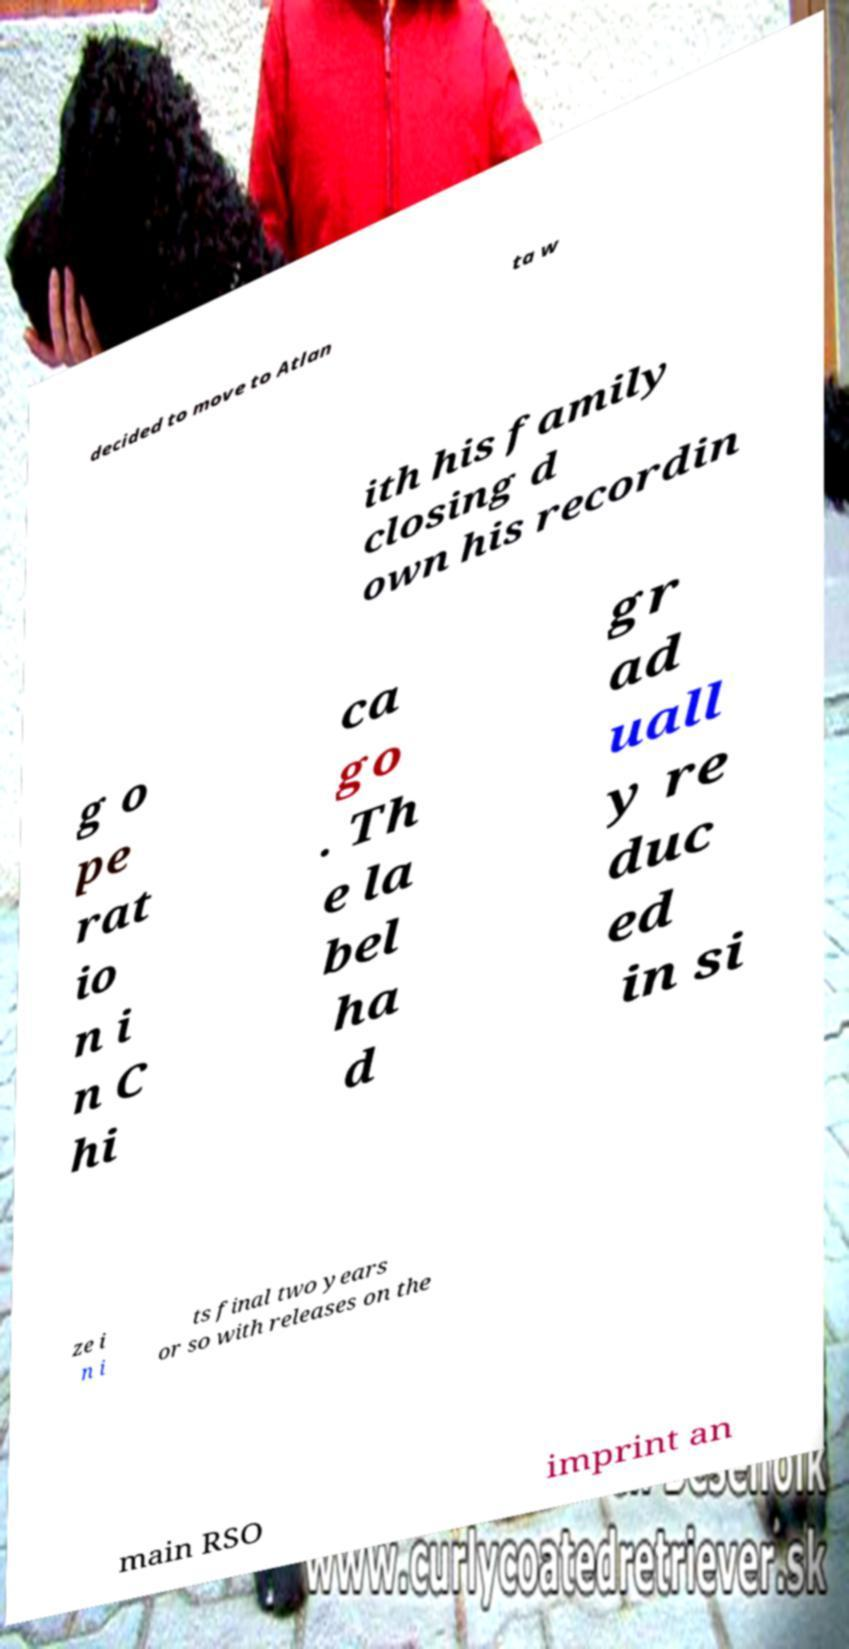Could you assist in decoding the text presented in this image and type it out clearly? decided to move to Atlan ta w ith his family closing d own his recordin g o pe rat io n i n C hi ca go . Th e la bel ha d gr ad uall y re duc ed in si ze i n i ts final two years or so with releases on the main RSO imprint an 